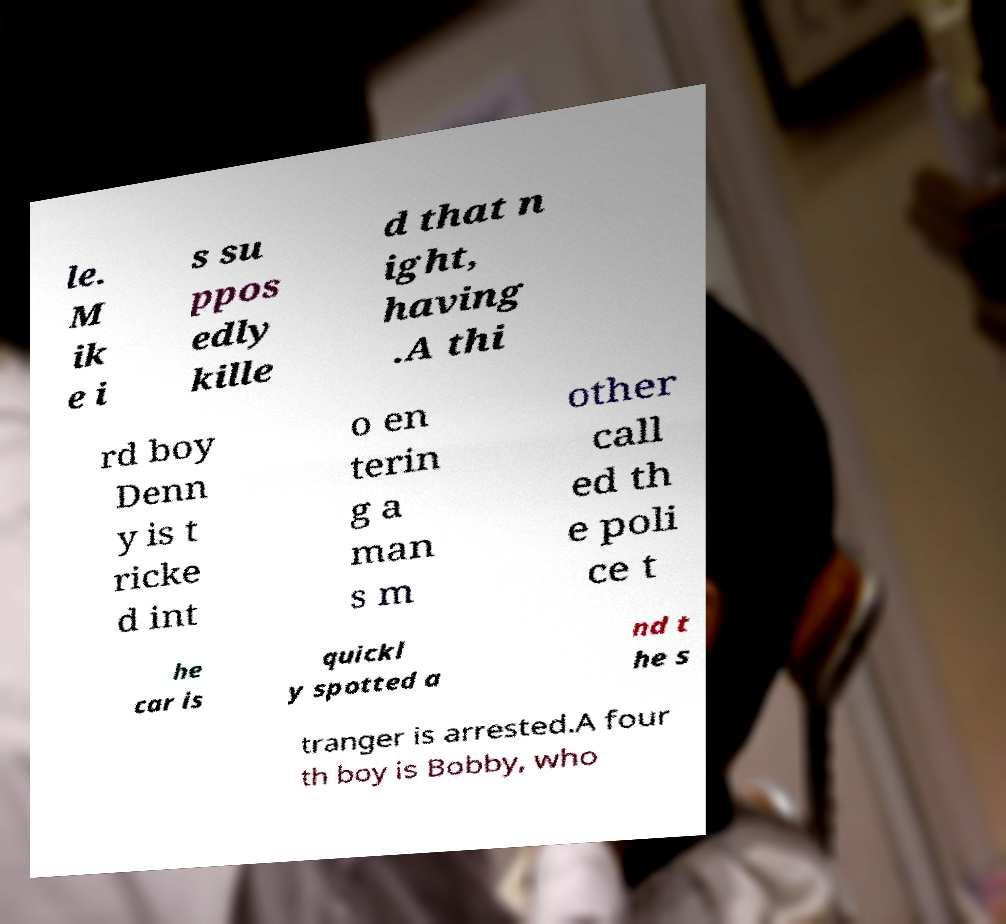Please identify and transcribe the text found in this image. le. M ik e i s su ppos edly kille d that n ight, having .A thi rd boy Denn y is t ricke d int o en terin g a man s m other call ed th e poli ce t he car is quickl y spotted a nd t he s tranger is arrested.A four th boy is Bobby, who 